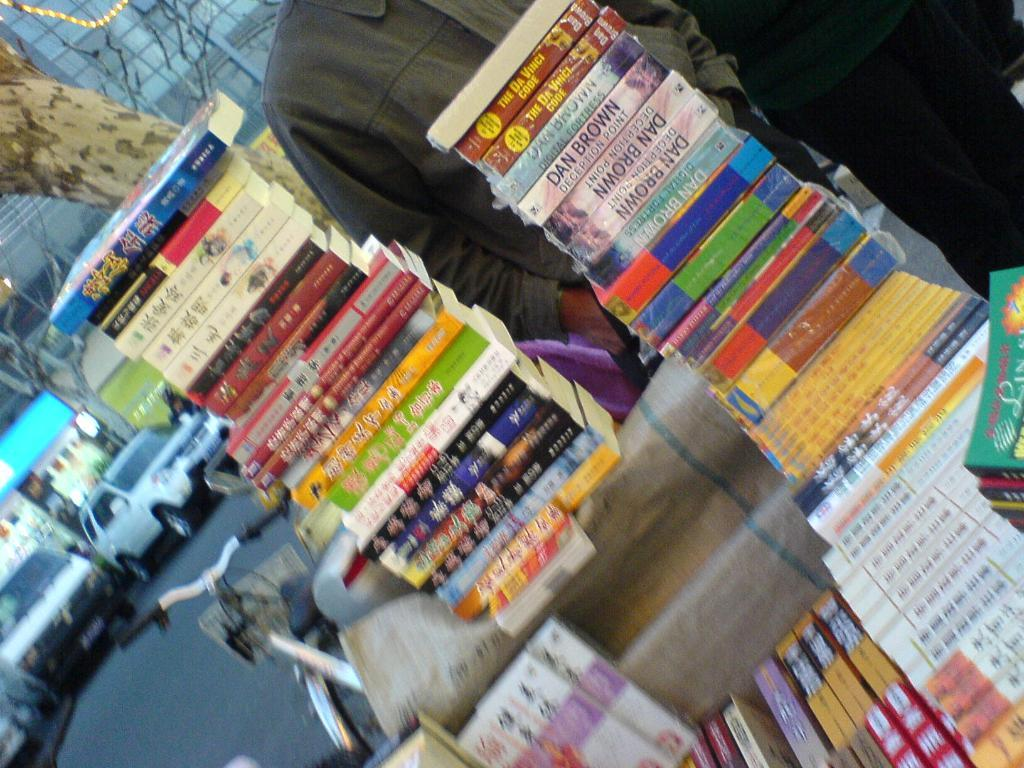Provide a one-sentence caption for the provided image. Stacks of books including the Da Vinci Code and Deception Point by Dan Brown. 